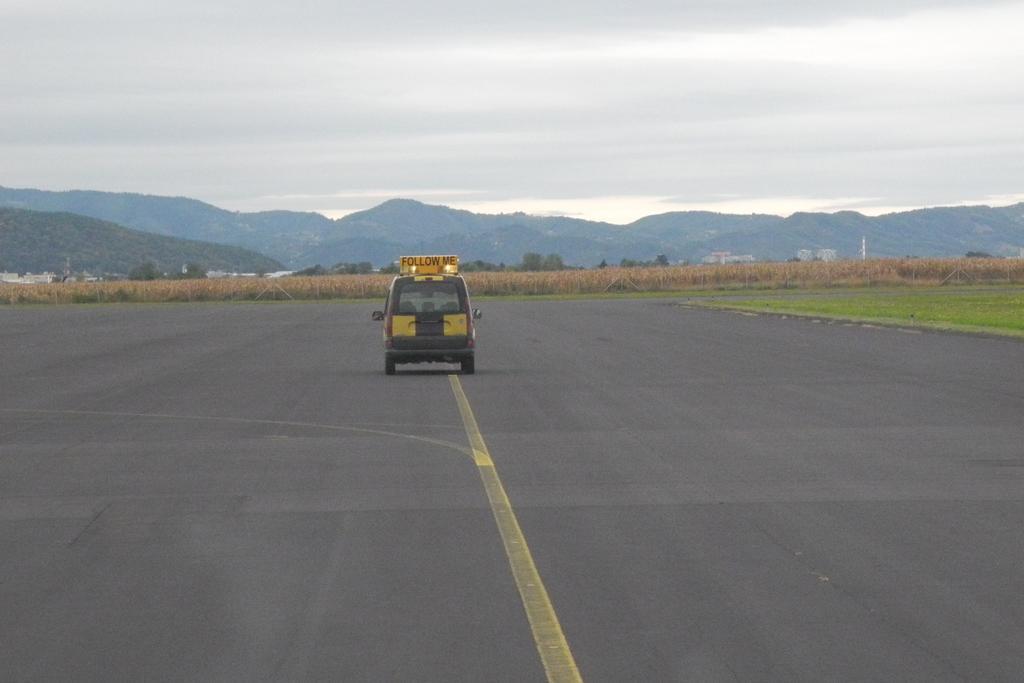Could you give a brief overview of what you see in this image? In this picture we can see a vehicle on the road. There is a text written on a yellow board. We can see a few plants, trees and mountains in the background. Sky is cloudy. 